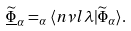<formula> <loc_0><loc_0><loc_500><loc_500>\underline { \widetilde { \Phi } } _ { \alpha } = _ { \alpha } \langle n \nu l \lambda | \widetilde { \Phi } _ { \alpha } \rangle .</formula> 